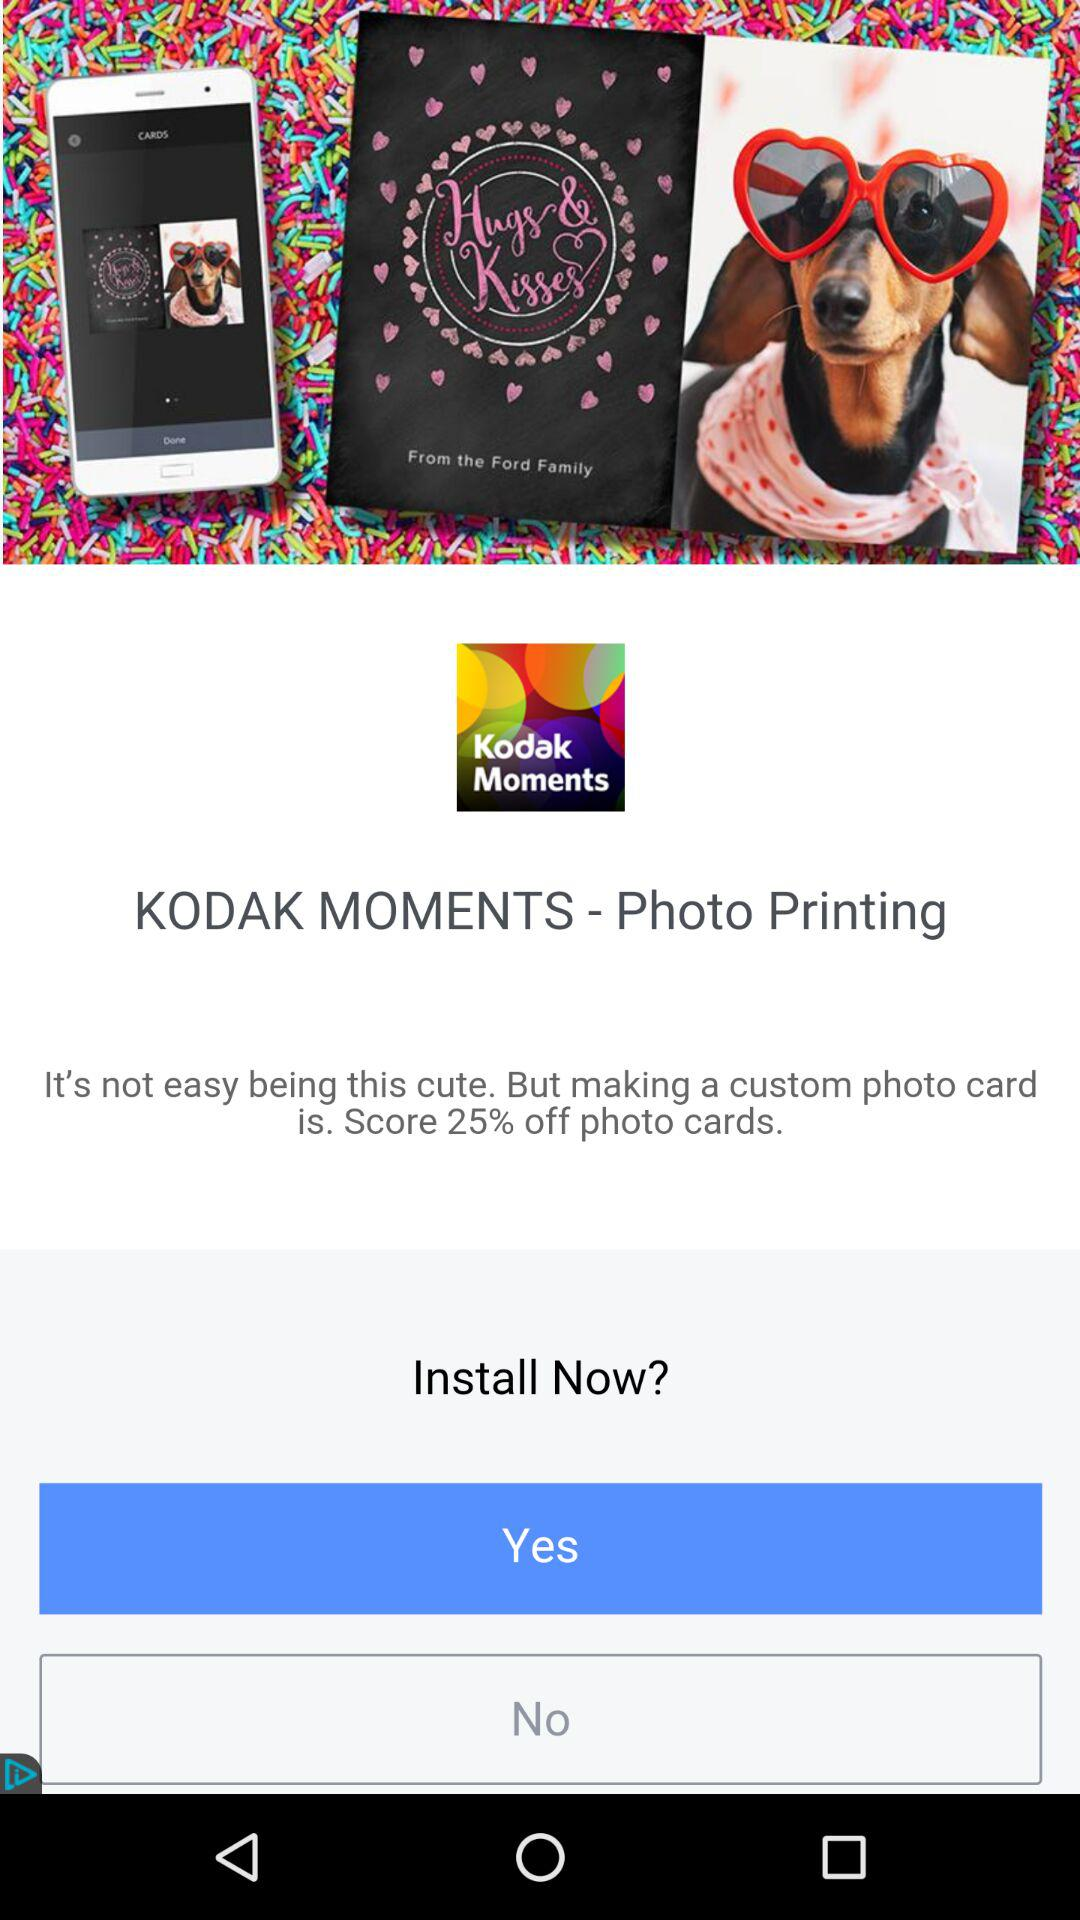How many percent off is the offer for photo cards?
Answer the question using a single word or phrase. 25% 